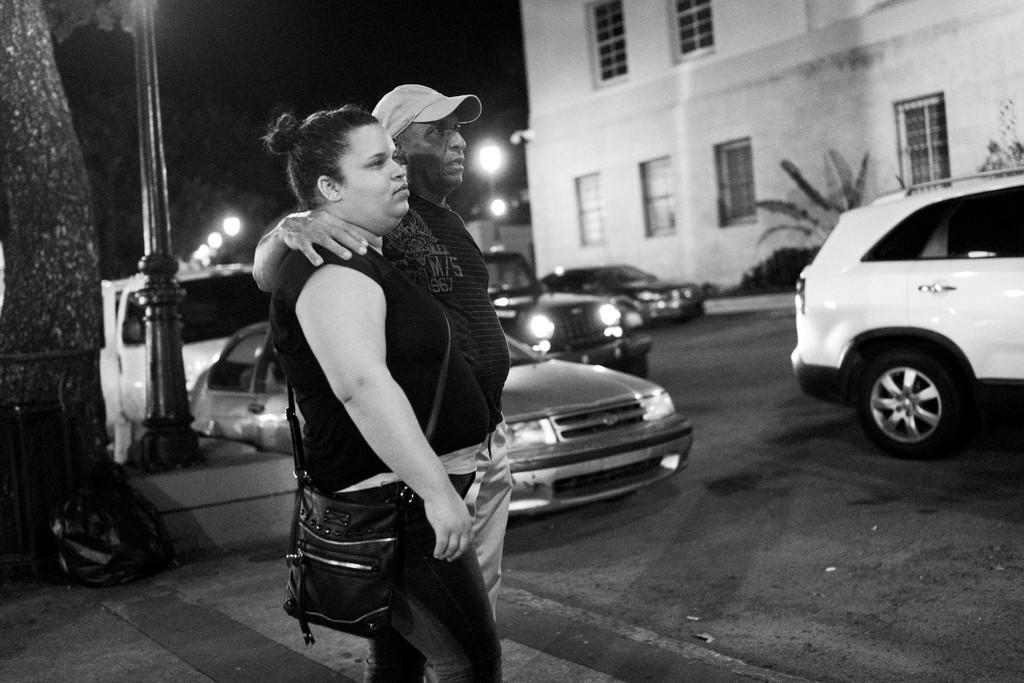In one or two sentences, can you explain what this image depicts? In this picture we can see a man and a woman are standing in the front, this woman is carrying a bag, there are some vehicles in the middle, on the left side there is a pole, we can see a building, lights and plants in the background, it is a black and white image. 